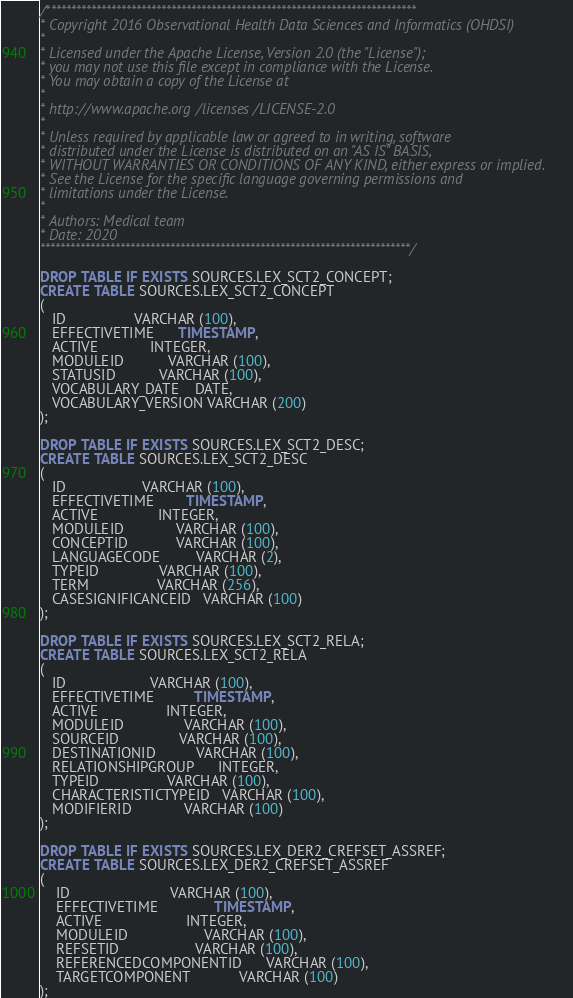<code> <loc_0><loc_0><loc_500><loc_500><_SQL_>/**************************************************************************
* Copyright 2016 Observational Health Data Sciences and Informatics (OHDSI)
*
* Licensed under the Apache License, Version 2.0 (the "License");
* you may not use this file except in compliance with the License.
* You may obtain a copy of the License at
*
* http://www.apache.org/licenses/LICENSE-2.0
*
* Unless required by applicable law or agreed to in writing, software
* distributed under the License is distributed on an "AS IS" BASIS,
* WITHOUT WARRANTIES OR CONDITIONS OF ANY KIND, either express or implied.
* See the License for the specific language governing permissions and
* limitations under the License.
* 
* Authors: Medical team
* Date: 2020
**************************************************************************/

DROP TABLE IF EXISTS SOURCES.LEX_SCT2_CONCEPT;
CREATE TABLE SOURCES.LEX_SCT2_CONCEPT
(
   ID                 VARCHAR (100),
   EFFECTIVETIME      TIMESTAMP,
   ACTIVE             INTEGER,
   MODULEID           VARCHAR (100),
   STATUSID           VARCHAR (100),
   VOCABULARY_DATE    DATE,
   VOCABULARY_VERSION VARCHAR (200)
);

DROP TABLE IF EXISTS SOURCES.LEX_SCT2_DESC;
CREATE TABLE SOURCES.LEX_SCT2_DESC
(
   ID                   VARCHAR (100),
   EFFECTIVETIME        TIMESTAMP,
   ACTIVE               INTEGER,
   MODULEID             VARCHAR (100),
   CONCEPTID            VARCHAR (100),
   LANGUAGECODE         VARCHAR (2),
   TYPEID               VARCHAR (100),
   TERM                 VARCHAR (256),
   CASESIGNIFICANCEID   VARCHAR (100)
);

DROP TABLE IF EXISTS SOURCES.LEX_SCT2_RELA;
CREATE TABLE SOURCES.LEX_SCT2_RELA
(
   ID                     VARCHAR (100),
   EFFECTIVETIME          TIMESTAMP,
   ACTIVE                 INTEGER,
   MODULEID               VARCHAR (100),
   SOURCEID               VARCHAR (100),
   DESTINATIONID          VARCHAR (100),
   RELATIONSHIPGROUP      INTEGER,
   TYPEID                 VARCHAR (100),
   CHARACTERISTICTYPEID   VARCHAR (100),
   MODIFIERID             VARCHAR (100)
);

DROP TABLE IF EXISTS SOURCES.LEX_DER2_CREFSET_ASSREF;
CREATE TABLE SOURCES.LEX_DER2_CREFSET_ASSREF
(
    ID                         VARCHAR (100),
    EFFECTIVETIME              TIMESTAMP,
    ACTIVE                     INTEGER,
    MODULEID                   VARCHAR (100),
    REFSETID                   VARCHAR (100),
    REFERENCEDCOMPONENTID      VARCHAR (100),
    TARGETCOMPONENT            VARCHAR (100)
);
</code> 